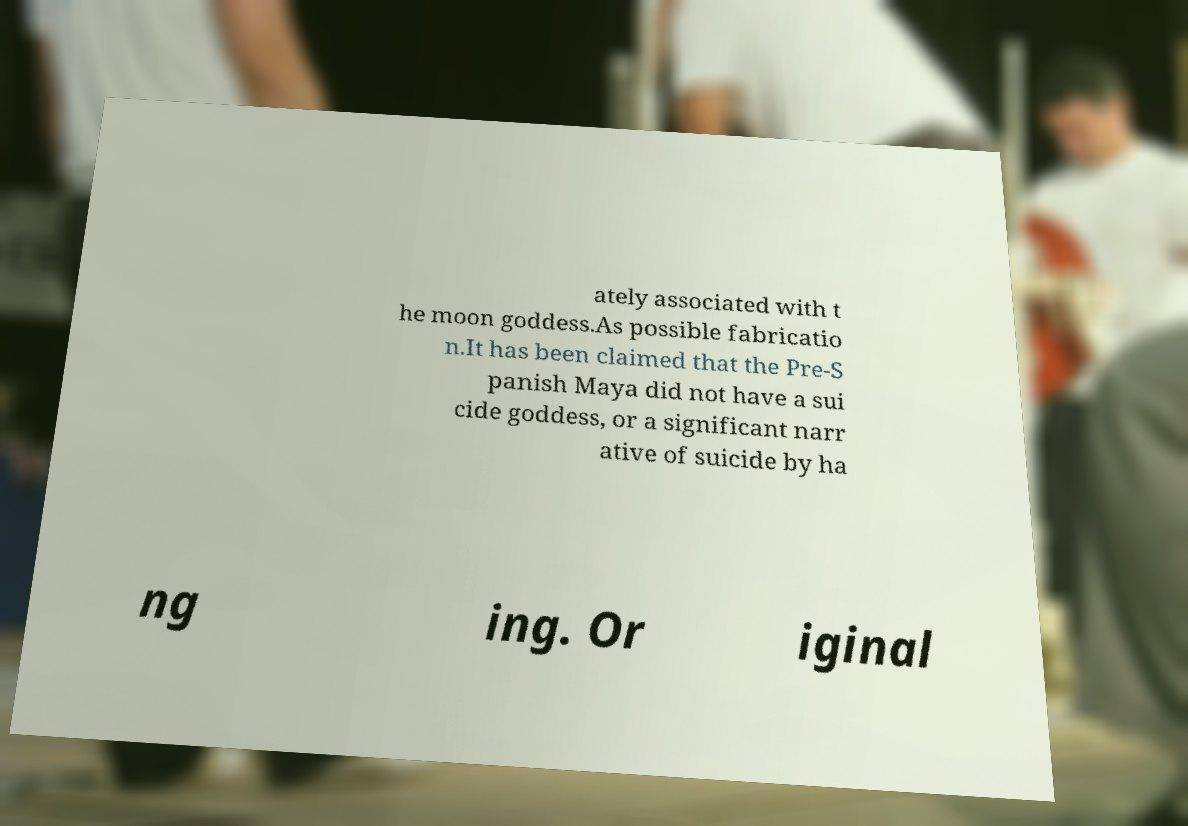Please read and relay the text visible in this image. What does it say? ately associated with t he moon goddess.As possible fabricatio n.It has been claimed that the Pre-S panish Maya did not have a sui cide goddess, or a significant narr ative of suicide by ha ng ing. Or iginal 